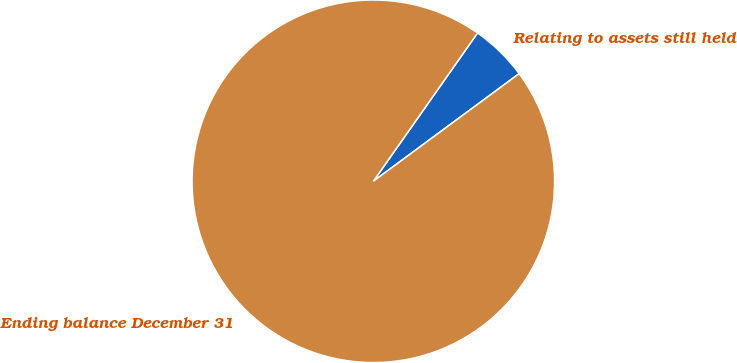<chart> <loc_0><loc_0><loc_500><loc_500><pie_chart><fcel>Relating to assets still held<fcel>Ending balance December 31<nl><fcel>5.13%<fcel>94.87%<nl></chart> 